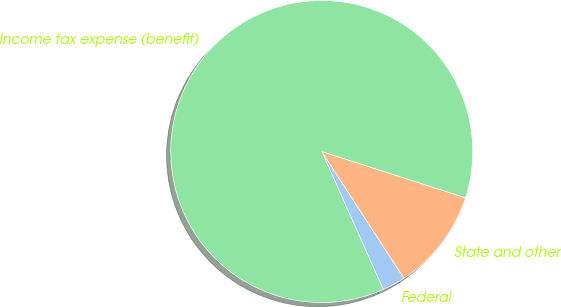Convert chart to OTSL. <chart><loc_0><loc_0><loc_500><loc_500><pie_chart><fcel>Federal<fcel>State and other<fcel>Income tax expense (benefit)<nl><fcel>2.48%<fcel>10.89%<fcel>86.63%<nl></chart> 